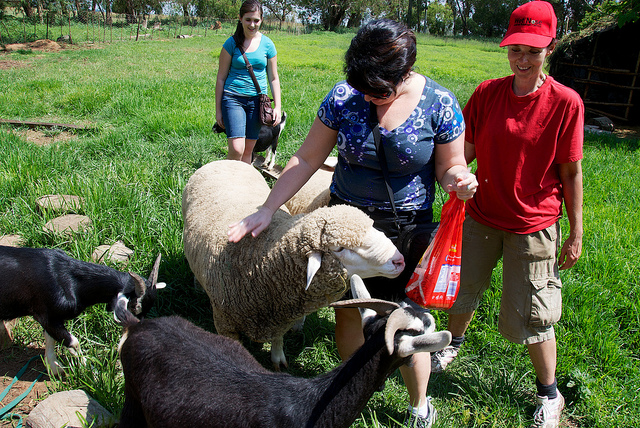If I wanted to feed the sheep, what would be the best type of food based on common knowledge? Sheep typically graze on grass, but if you're looking to give them a treat or supplementary feed, alfalfa hay, high-quality pelleted grain rations, or specialized sheep feed are good options. It's essential to ensure any food given is suitable for sheep, avoid overfeeding, and make certain the food doesn't contain any substances that might be toxic to them. 